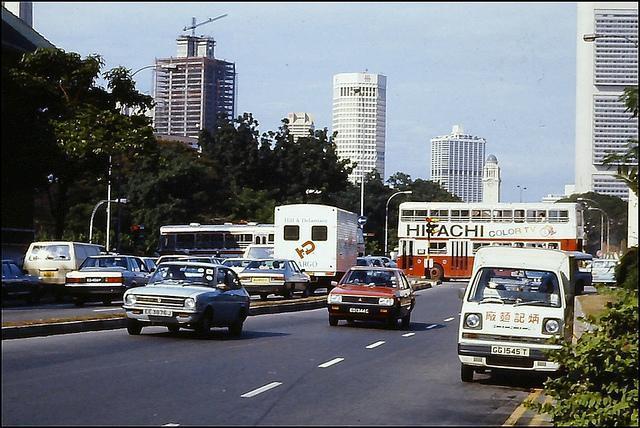How many buses are there?
Give a very brief answer. 2. How many trucks can you see?
Give a very brief answer. 3. How many cars are in the photo?
Give a very brief answer. 5. 